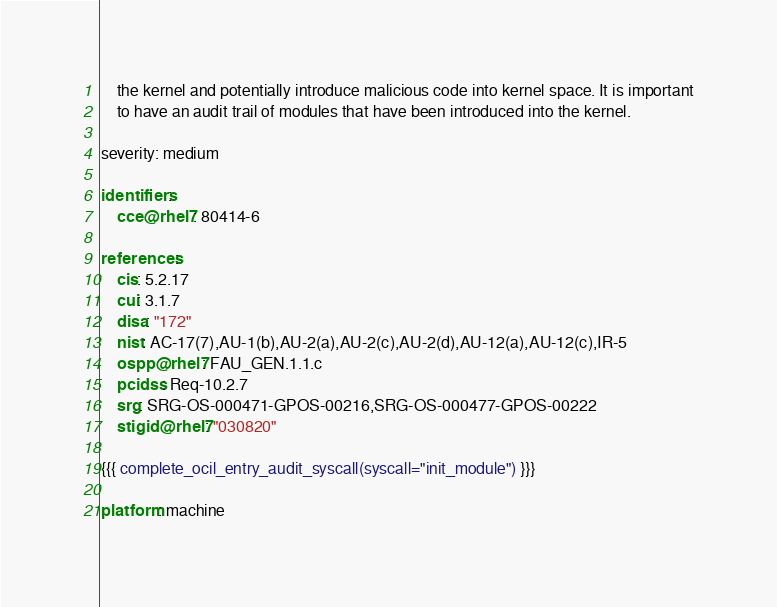<code> <loc_0><loc_0><loc_500><loc_500><_YAML_>    the kernel and potentially introduce malicious code into kernel space. It is important
    to have an audit trail of modules that have been introduced into the kernel.

severity: medium

identifiers:
    cce@rhel7: 80414-6

references:
    cis: 5.2.17
    cui: 3.1.7
    disa: "172"
    nist: AC-17(7),AU-1(b),AU-2(a),AU-2(c),AU-2(d),AU-12(a),AU-12(c),IR-5
    ospp@rhel7: FAU_GEN.1.1.c
    pcidss: Req-10.2.7
    srg: SRG-OS-000471-GPOS-00216,SRG-OS-000477-GPOS-00222
    stigid@rhel7: "030820"

{{{ complete_ocil_entry_audit_syscall(syscall="init_module") }}}

platform: machine
</code> 